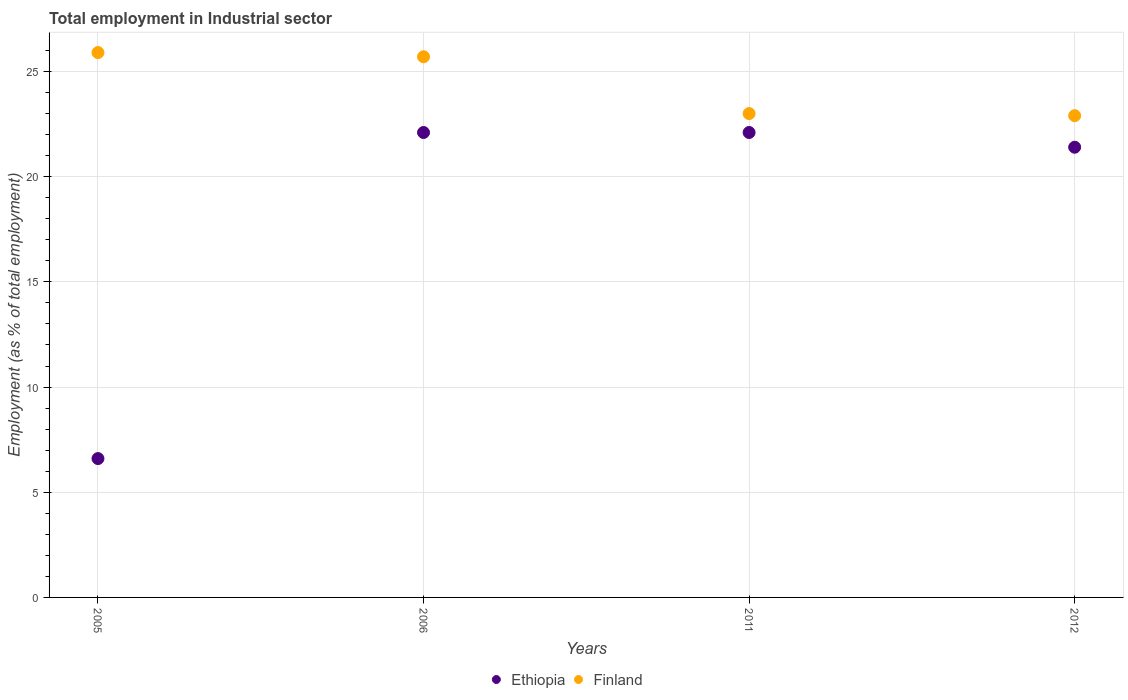How many different coloured dotlines are there?
Your response must be concise. 2. Is the number of dotlines equal to the number of legend labels?
Give a very brief answer. Yes. What is the employment in industrial sector in Ethiopia in 2012?
Your answer should be very brief. 21.4. Across all years, what is the maximum employment in industrial sector in Finland?
Your answer should be compact. 25.9. Across all years, what is the minimum employment in industrial sector in Ethiopia?
Make the answer very short. 6.6. In which year was the employment in industrial sector in Ethiopia maximum?
Keep it short and to the point. 2006. What is the total employment in industrial sector in Finland in the graph?
Offer a terse response. 97.5. What is the difference between the employment in industrial sector in Ethiopia in 2006 and the employment in industrial sector in Finland in 2012?
Provide a short and direct response. -0.8. What is the average employment in industrial sector in Finland per year?
Provide a short and direct response. 24.38. In the year 2005, what is the difference between the employment in industrial sector in Finland and employment in industrial sector in Ethiopia?
Give a very brief answer. 19.3. In how many years, is the employment in industrial sector in Ethiopia greater than 21 %?
Provide a short and direct response. 3. What is the ratio of the employment in industrial sector in Ethiopia in 2005 to that in 2006?
Ensure brevity in your answer.  0.3. What is the difference between the highest and the second highest employment in industrial sector in Finland?
Your response must be concise. 0.2. What is the difference between the highest and the lowest employment in industrial sector in Finland?
Keep it short and to the point. 3. Is the sum of the employment in industrial sector in Finland in 2006 and 2011 greater than the maximum employment in industrial sector in Ethiopia across all years?
Offer a terse response. Yes. Does the employment in industrial sector in Ethiopia monotonically increase over the years?
Provide a short and direct response. No. Is the employment in industrial sector in Finland strictly greater than the employment in industrial sector in Ethiopia over the years?
Your response must be concise. Yes. How many dotlines are there?
Ensure brevity in your answer.  2. How many years are there in the graph?
Ensure brevity in your answer.  4. Are the values on the major ticks of Y-axis written in scientific E-notation?
Provide a succinct answer. No. Does the graph contain any zero values?
Your answer should be compact. No. Where does the legend appear in the graph?
Give a very brief answer. Bottom center. How many legend labels are there?
Keep it short and to the point. 2. How are the legend labels stacked?
Your answer should be very brief. Horizontal. What is the title of the graph?
Your response must be concise. Total employment in Industrial sector. What is the label or title of the X-axis?
Offer a very short reply. Years. What is the label or title of the Y-axis?
Keep it short and to the point. Employment (as % of total employment). What is the Employment (as % of total employment) of Ethiopia in 2005?
Offer a very short reply. 6.6. What is the Employment (as % of total employment) in Finland in 2005?
Keep it short and to the point. 25.9. What is the Employment (as % of total employment) of Ethiopia in 2006?
Provide a succinct answer. 22.1. What is the Employment (as % of total employment) in Finland in 2006?
Keep it short and to the point. 25.7. What is the Employment (as % of total employment) of Ethiopia in 2011?
Make the answer very short. 22.1. What is the Employment (as % of total employment) in Ethiopia in 2012?
Your answer should be compact. 21.4. What is the Employment (as % of total employment) of Finland in 2012?
Offer a very short reply. 22.9. Across all years, what is the maximum Employment (as % of total employment) in Ethiopia?
Make the answer very short. 22.1. Across all years, what is the maximum Employment (as % of total employment) of Finland?
Your response must be concise. 25.9. Across all years, what is the minimum Employment (as % of total employment) of Ethiopia?
Give a very brief answer. 6.6. Across all years, what is the minimum Employment (as % of total employment) in Finland?
Give a very brief answer. 22.9. What is the total Employment (as % of total employment) in Ethiopia in the graph?
Provide a succinct answer. 72.2. What is the total Employment (as % of total employment) in Finland in the graph?
Offer a very short reply. 97.5. What is the difference between the Employment (as % of total employment) in Ethiopia in 2005 and that in 2006?
Keep it short and to the point. -15.5. What is the difference between the Employment (as % of total employment) in Ethiopia in 2005 and that in 2011?
Offer a terse response. -15.5. What is the difference between the Employment (as % of total employment) of Ethiopia in 2005 and that in 2012?
Make the answer very short. -14.8. What is the difference between the Employment (as % of total employment) in Finland in 2005 and that in 2012?
Make the answer very short. 3. What is the difference between the Employment (as % of total employment) of Finland in 2006 and that in 2011?
Your answer should be very brief. 2.7. What is the difference between the Employment (as % of total employment) in Ethiopia in 2006 and that in 2012?
Make the answer very short. 0.7. What is the difference between the Employment (as % of total employment) of Ethiopia in 2005 and the Employment (as % of total employment) of Finland in 2006?
Provide a short and direct response. -19.1. What is the difference between the Employment (as % of total employment) of Ethiopia in 2005 and the Employment (as % of total employment) of Finland in 2011?
Provide a short and direct response. -16.4. What is the difference between the Employment (as % of total employment) of Ethiopia in 2005 and the Employment (as % of total employment) of Finland in 2012?
Provide a succinct answer. -16.3. What is the difference between the Employment (as % of total employment) in Ethiopia in 2006 and the Employment (as % of total employment) in Finland in 2012?
Provide a short and direct response. -0.8. What is the difference between the Employment (as % of total employment) of Ethiopia in 2011 and the Employment (as % of total employment) of Finland in 2012?
Keep it short and to the point. -0.8. What is the average Employment (as % of total employment) in Ethiopia per year?
Provide a succinct answer. 18.05. What is the average Employment (as % of total employment) of Finland per year?
Your answer should be very brief. 24.38. In the year 2005, what is the difference between the Employment (as % of total employment) in Ethiopia and Employment (as % of total employment) in Finland?
Your answer should be compact. -19.3. In the year 2006, what is the difference between the Employment (as % of total employment) of Ethiopia and Employment (as % of total employment) of Finland?
Provide a succinct answer. -3.6. In the year 2011, what is the difference between the Employment (as % of total employment) of Ethiopia and Employment (as % of total employment) of Finland?
Provide a succinct answer. -0.9. What is the ratio of the Employment (as % of total employment) in Ethiopia in 2005 to that in 2006?
Ensure brevity in your answer.  0.3. What is the ratio of the Employment (as % of total employment) of Ethiopia in 2005 to that in 2011?
Give a very brief answer. 0.3. What is the ratio of the Employment (as % of total employment) in Finland in 2005 to that in 2011?
Ensure brevity in your answer.  1.13. What is the ratio of the Employment (as % of total employment) in Ethiopia in 2005 to that in 2012?
Your answer should be compact. 0.31. What is the ratio of the Employment (as % of total employment) in Finland in 2005 to that in 2012?
Your response must be concise. 1.13. What is the ratio of the Employment (as % of total employment) of Finland in 2006 to that in 2011?
Your response must be concise. 1.12. What is the ratio of the Employment (as % of total employment) in Ethiopia in 2006 to that in 2012?
Provide a short and direct response. 1.03. What is the ratio of the Employment (as % of total employment) of Finland in 2006 to that in 2012?
Keep it short and to the point. 1.12. What is the ratio of the Employment (as % of total employment) of Ethiopia in 2011 to that in 2012?
Give a very brief answer. 1.03. What is the difference between the highest and the second highest Employment (as % of total employment) in Finland?
Your answer should be very brief. 0.2. 